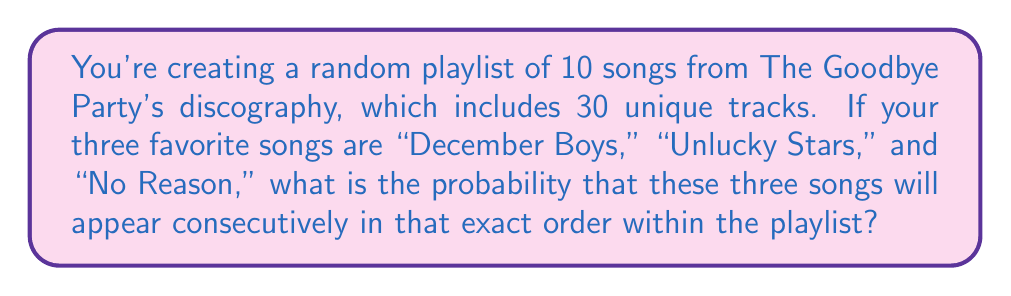Give your solution to this math problem. Let's approach this step-by-step:

1) First, we need to calculate the probability of selecting these three specific songs in the given order:

   $P(\text{3 specific songs}) = \frac{1}{30} \cdot \frac{1}{29} \cdot \frac{1}{28} = \frac{1}{24360}$

2) Now, we need to consider the number of possible positions where this sequence of 3 songs can start within a 10-song playlist. The sequence can start at positions 1, 2, 3, 4, 5, 6, 7, or 8. That's 8 possible starting positions.

3) The probability of the sequence occurring in any one of these positions is the same as we calculated in step 1. Since these are mutually exclusive events (the sequence can't start in more than one position simultaneously), we can add these probabilities:

   $P(\text{sequence in playlist}) = 8 \cdot \frac{1}{24360} = \frac{1}{3045}$

4) Therefore, the probability of these three songs appearing consecutively in that exact order within the playlist is $\frac{1}{3045}$.
Answer: $\frac{1}{3045}$ 